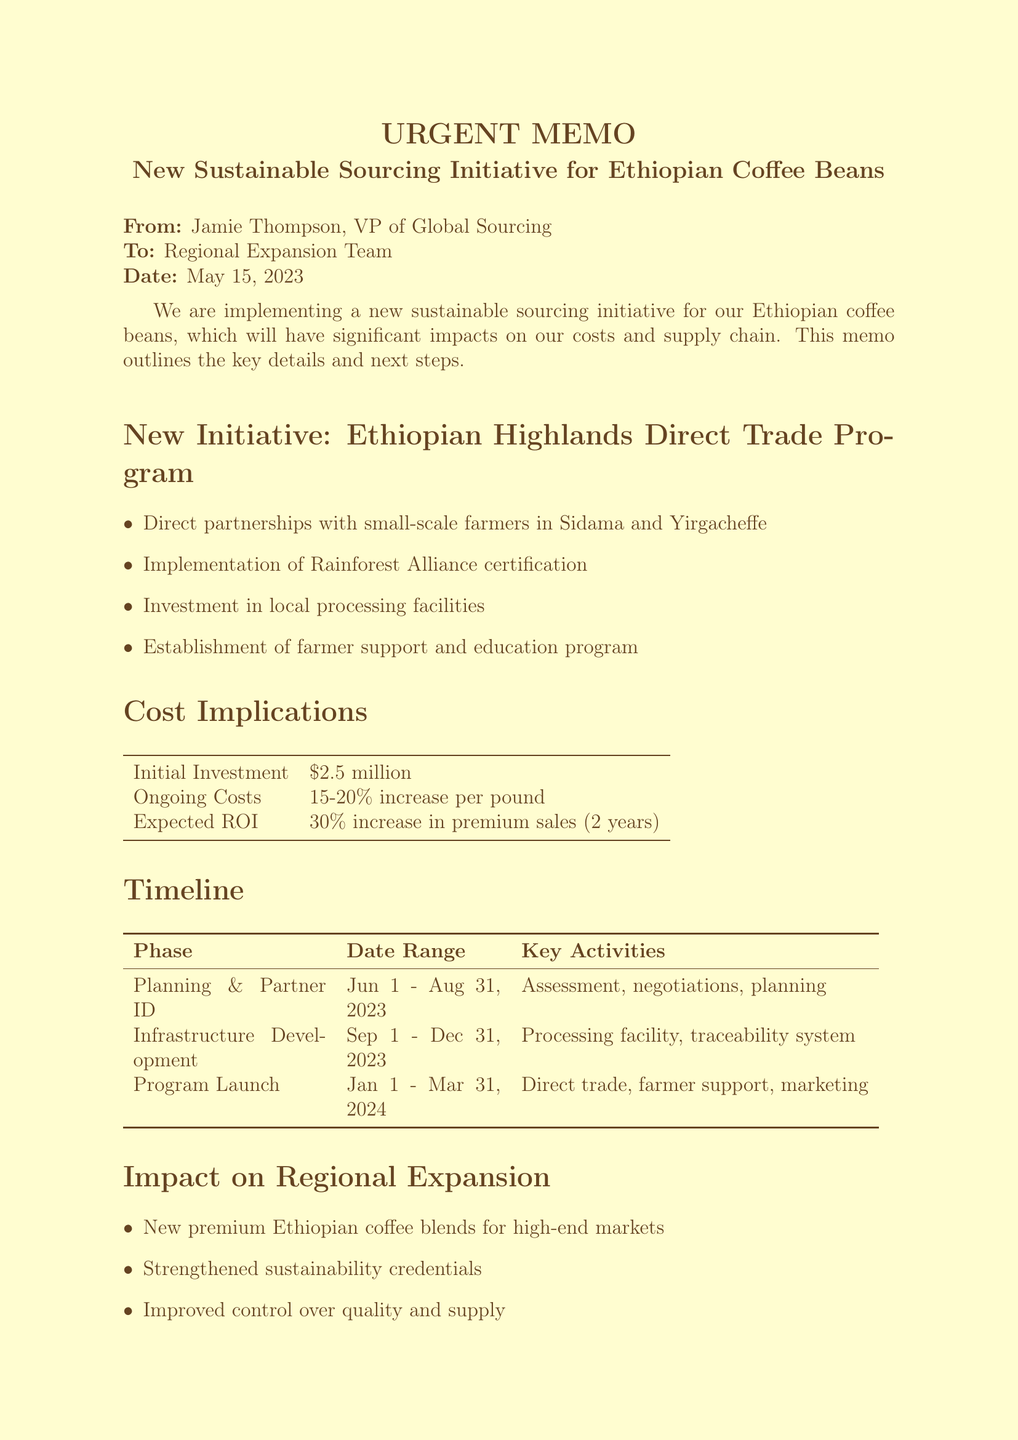What is the title of the memo? The title of the memo is mentioned at the beginning, which is "Urgent: New Sustainable Sourcing Initiative for Ethiopian Coffee Beans."
Answer: Urgent: New Sustainable Sourcing Initiative for Ethiopian Coffee Beans Who sent the memo? The sender, identified at the top, is Jamie Thompson, VP of Global Sourcing.
Answer: Jamie Thompson What is the initial investment for the new initiative? The cost implications section specifies that the initial investment is $2.5 million.
Answer: $2.5 million What is the expected ROI? In the cost implications section, the expected return on investment (ROI) is stated as a 30% increase in premium coffee sales within 2 years.
Answer: 30% increase in premium coffee sales within 2 years What are the dates for the Planning and Partner Identification phase? The timeline section outlines the date range for this phase as June 1 to August 31, 2023.
Answer: June 1 - August 31, 2023 Which regions will the small-scale farmers be located in? The new initiative section indicates that farmers are located in the Sidama and Yirgacheffe regions.
Answer: Sidama and Yirgacheffe What is one key feature of the Ethiopian Highlands Direct Trade Program? The memo lists several key features, one of which is the establishment of a farmer support and education program.
Answer: Farmer support and education program What is the scheduled date for the cross-functional kick-off meeting? The next steps section specifies that the cross-functional kick-off meeting is scheduled for June 5, 2023.
Answer: June 5, 2023 What is one impact of the new initiative on regional expansion? One impact mentioned is strengthened sustainability credentials to support entry into environmentally conscious markets.
Answer: Strengthened sustainability credentials 